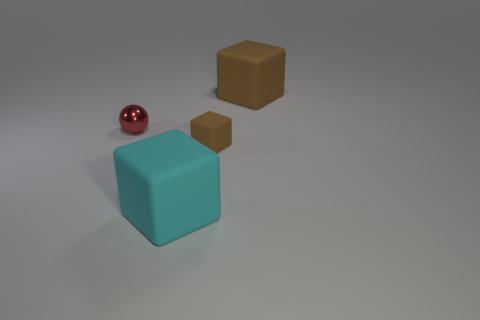How many brown cubes are the same size as the cyan object?
Keep it short and to the point. 1. There is a big rubber object behind the small brown block; are there any cyan matte objects that are in front of it?
Make the answer very short. Yes. What number of brown things are either blocks or tiny blocks?
Provide a succinct answer. 2. The small sphere has what color?
Your answer should be compact. Red. What size is the brown block that is made of the same material as the large brown object?
Provide a short and direct response. Small. How many small red metallic objects are the same shape as the cyan object?
Offer a terse response. 0. What size is the brown block that is in front of the large rubber block behind the cyan matte thing?
Your answer should be compact. Small. What is the material of the thing that is the same size as the red metallic ball?
Provide a succinct answer. Rubber. Is there another brown block that has the same material as the tiny brown cube?
Offer a very short reply. Yes. What color is the big block in front of the big thing behind the big thing in front of the big brown rubber object?
Provide a short and direct response. Cyan. 